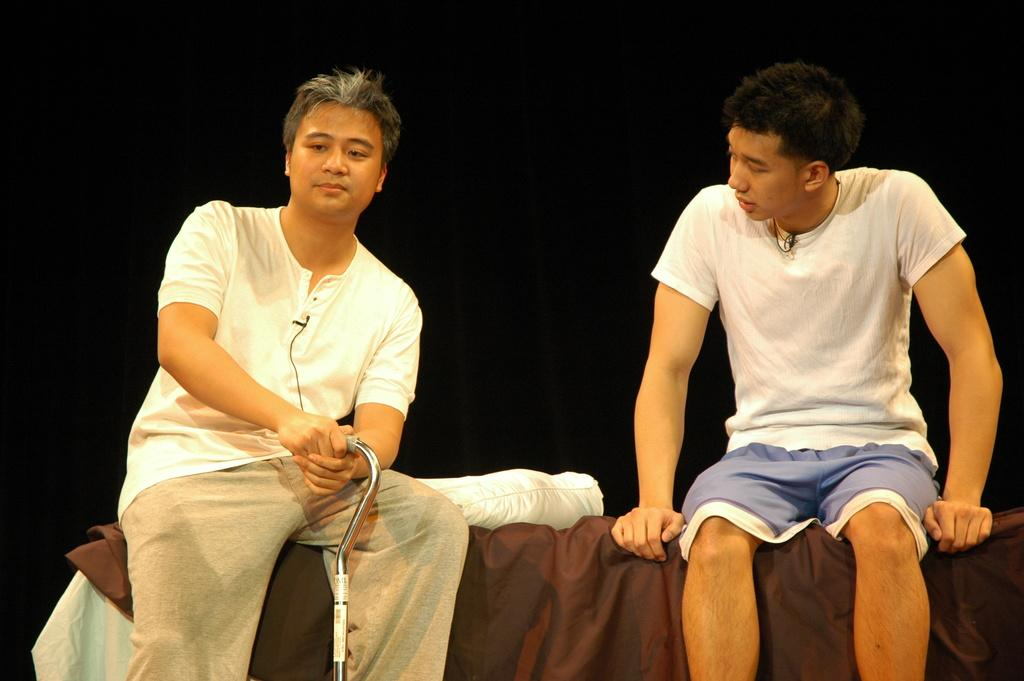How many people are in the image? There are two men in the image. What are the men doing in the image? The men are sitting on cloth. Can you describe the object being held by one of the men? One of the men is holding an object. What type of furniture is visible in the image? There is a pillow visible in the image. What is the lighting condition in the image? The background of the image is dark. What type of company is being discussed by the men in the image? There is no indication in the image that the men are discussing any company. 